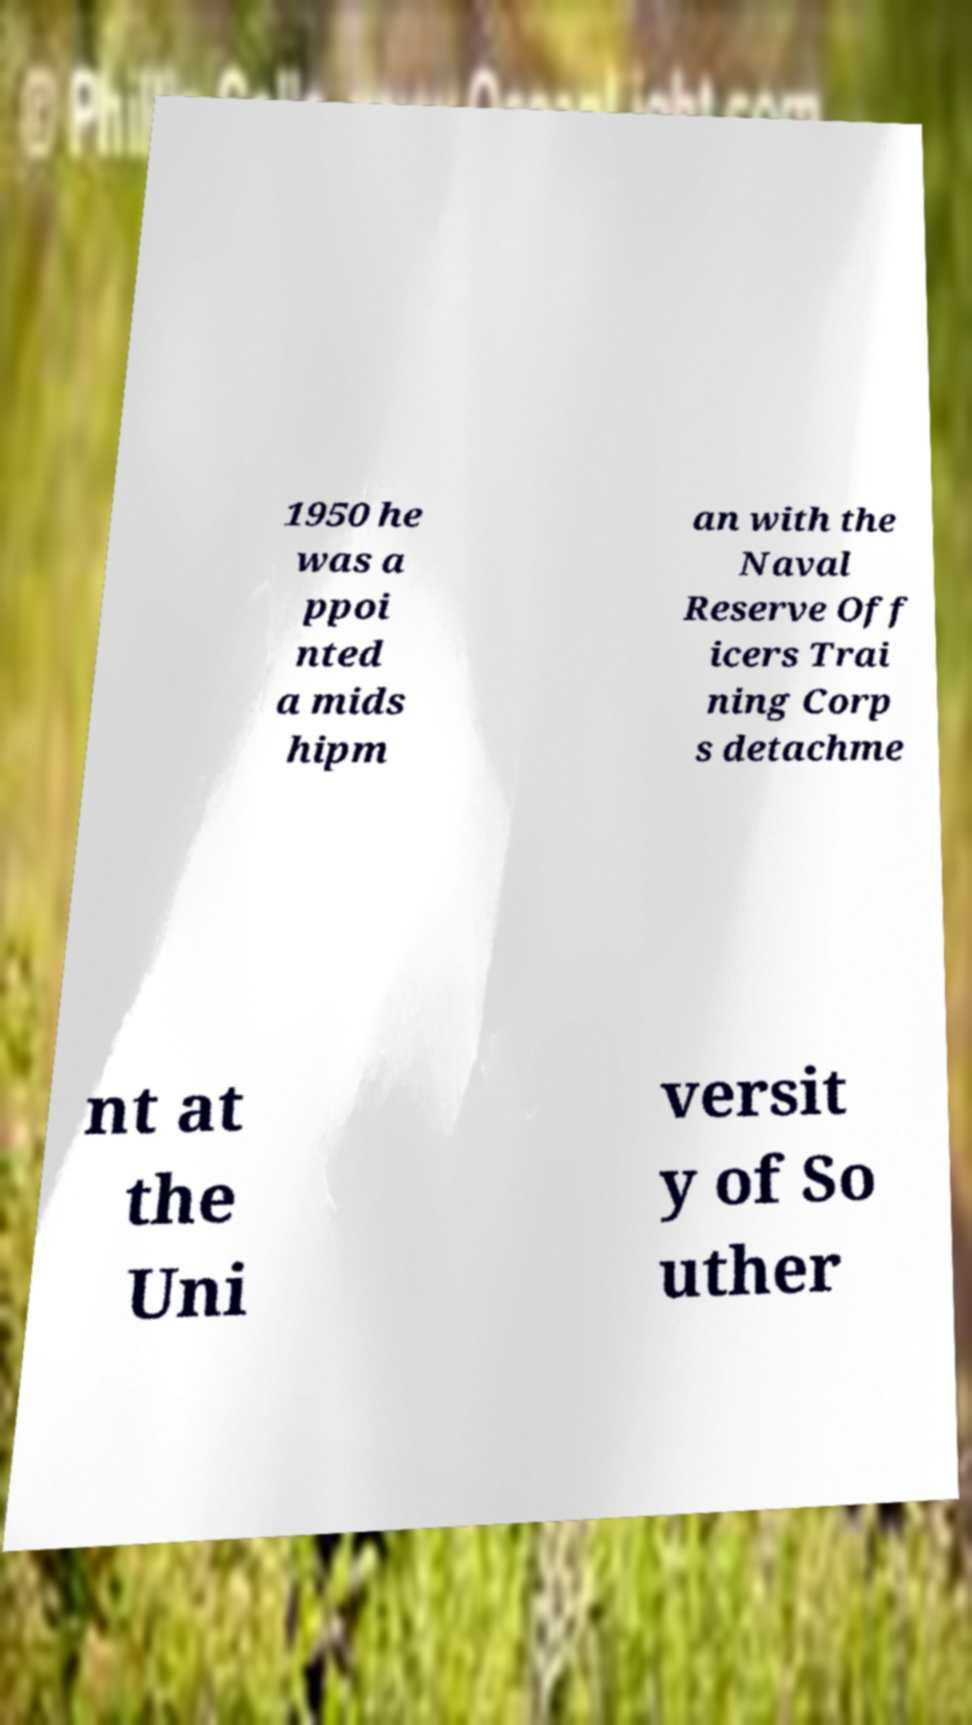Please identify and transcribe the text found in this image. 1950 he was a ppoi nted a mids hipm an with the Naval Reserve Off icers Trai ning Corp s detachme nt at the Uni versit y of So uther 